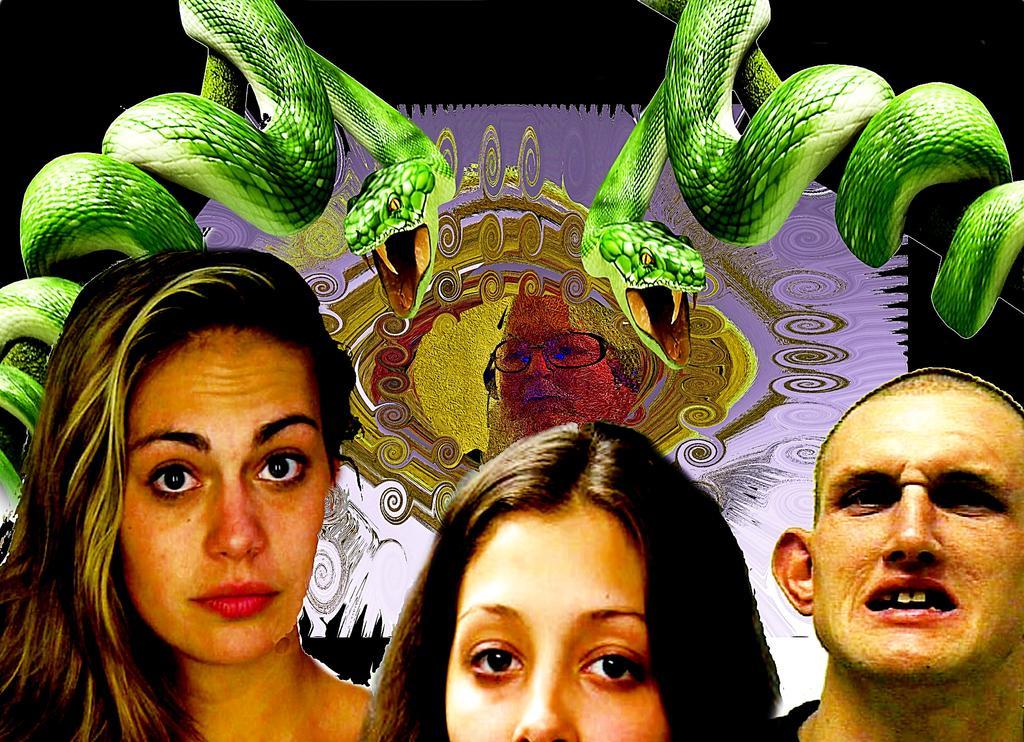Please provide a concise description of this image. Here we can see three persons. There are snakes and picture of a person on the banner. There is a dark background. 